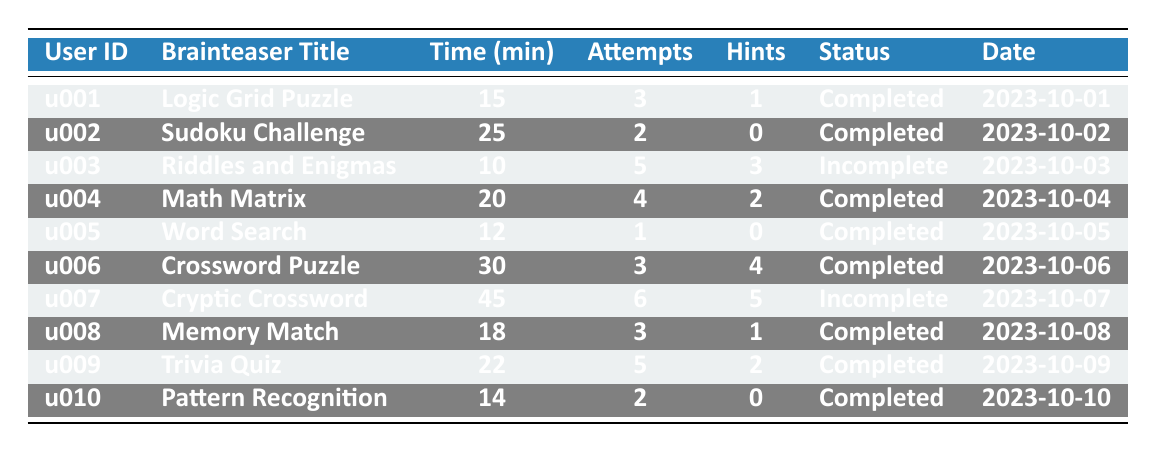What is the title of the brainteaser played by user u005? The table states that user u005 played the "Word Search" brainteaser.
Answer: Word Search How many attempts did user u006 make? According to the table, user u006 made 3 attempts while playing the "Crossword Puzzle."
Answer: 3 Which brainteaser required the most hints? The "Cryptic Crossword" by user u007 required 5 hints, which is the highest count in the table.
Answer: Cryptic Crossword What is the total time spent by all users on brainteasers listed? Adding the time spent by all users: 15 + 25 + 10 + 20 + 12 + 30 + 45 + 18 + 22 + 14 =  201 minutes.
Answer: 201 minutes Which user has the highest number of attempts, and how many attempts did they make? User u007 has the highest number of attempts at 6 while playing the "Cryptic Crossword."
Answer: u007, 6 attempts Did user u003 complete their brainteaser? User u003 did not complete the brainteaser as their status is marked as "Incomplete."
Answer: No On which date was the "Trivia Quiz" played? The "Trivia Quiz" was played by user u009 on 2023-10-09, as indicated in the table.
Answer: 2023-10-09 What is the average time spent by users on the completed brainteasers? The sum of time for completed brainteasers = 15 + 25 + 20 + 12 + 30 + 18 + 22 + 14 =  152. The number of completed brainteasers is 8, so the average is 152/8 = 19 minutes.
Answer: 19 minutes Which brainteaser had the smallest time spent by a user? User u005 spent the least amount of time, which is 12 minutes on the "Word Search."
Answer: Word Search, 12 minutes Are there any brainteasers where no hints were used? Yes, users u002 and u005 did not use hints while completing "Sudoku Challenge" and "Word Search," respectively.
Answer: Yes 